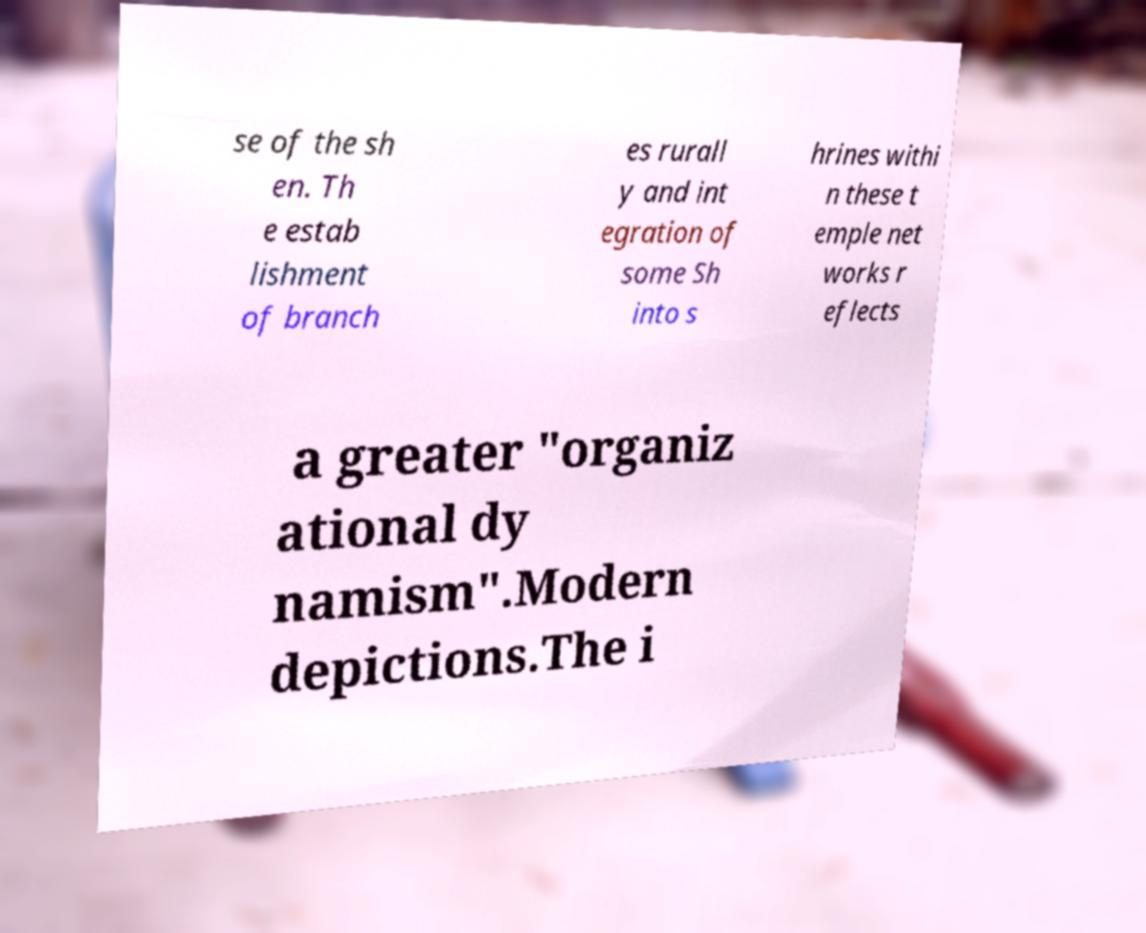Can you read and provide the text displayed in the image?This photo seems to have some interesting text. Can you extract and type it out for me? se of the sh en. Th e estab lishment of branch es rurall y and int egration of some Sh into s hrines withi n these t emple net works r eflects a greater "organiz ational dy namism".Modern depictions.The i 